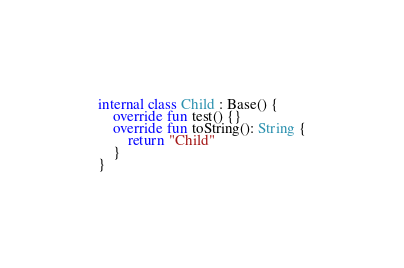Convert code to text. <code><loc_0><loc_0><loc_500><loc_500><_Kotlin_>
internal class Child : Base() {
    override fun test() {}
    override fun toString(): String {
        return "Child"
    }
}
</code> 